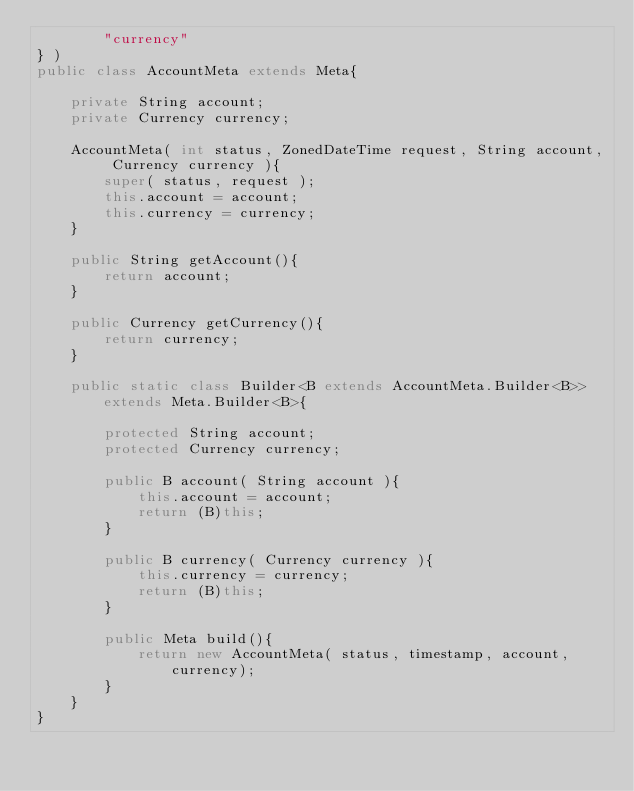Convert code to text. <code><loc_0><loc_0><loc_500><loc_500><_Java_>        "currency"
} )
public class AccountMeta extends Meta{

    private String account;
    private Currency currency;

    AccountMeta( int status, ZonedDateTime request, String account, Currency currency ){
        super( status, request );
        this.account = account;
        this.currency = currency;
    }

    public String getAccount(){
        return account;
    }

    public Currency getCurrency(){
        return currency;
    }

    public static class Builder<B extends AccountMeta.Builder<B>> extends Meta.Builder<B>{

        protected String account;
        protected Currency currency;

        public B account( String account ){
            this.account = account;
            return (B)this;
        }

        public B currency( Currency currency ){
            this.currency = currency;
            return (B)this;
        }

        public Meta build(){
            return new AccountMeta( status, timestamp, account, currency);
        }
    }
}
</code> 